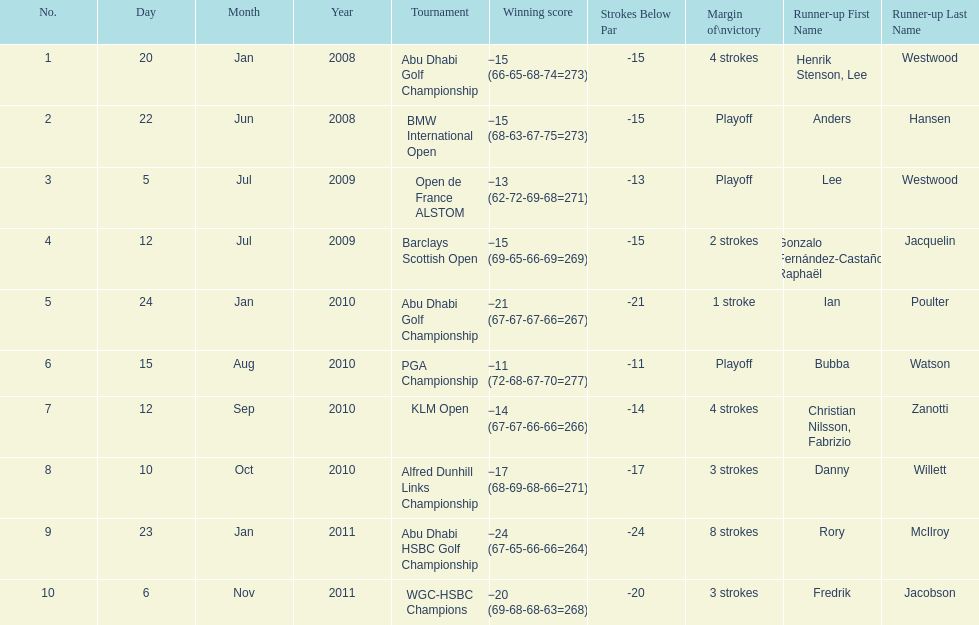How many tournaments has he won by 3 or more strokes? 5. 